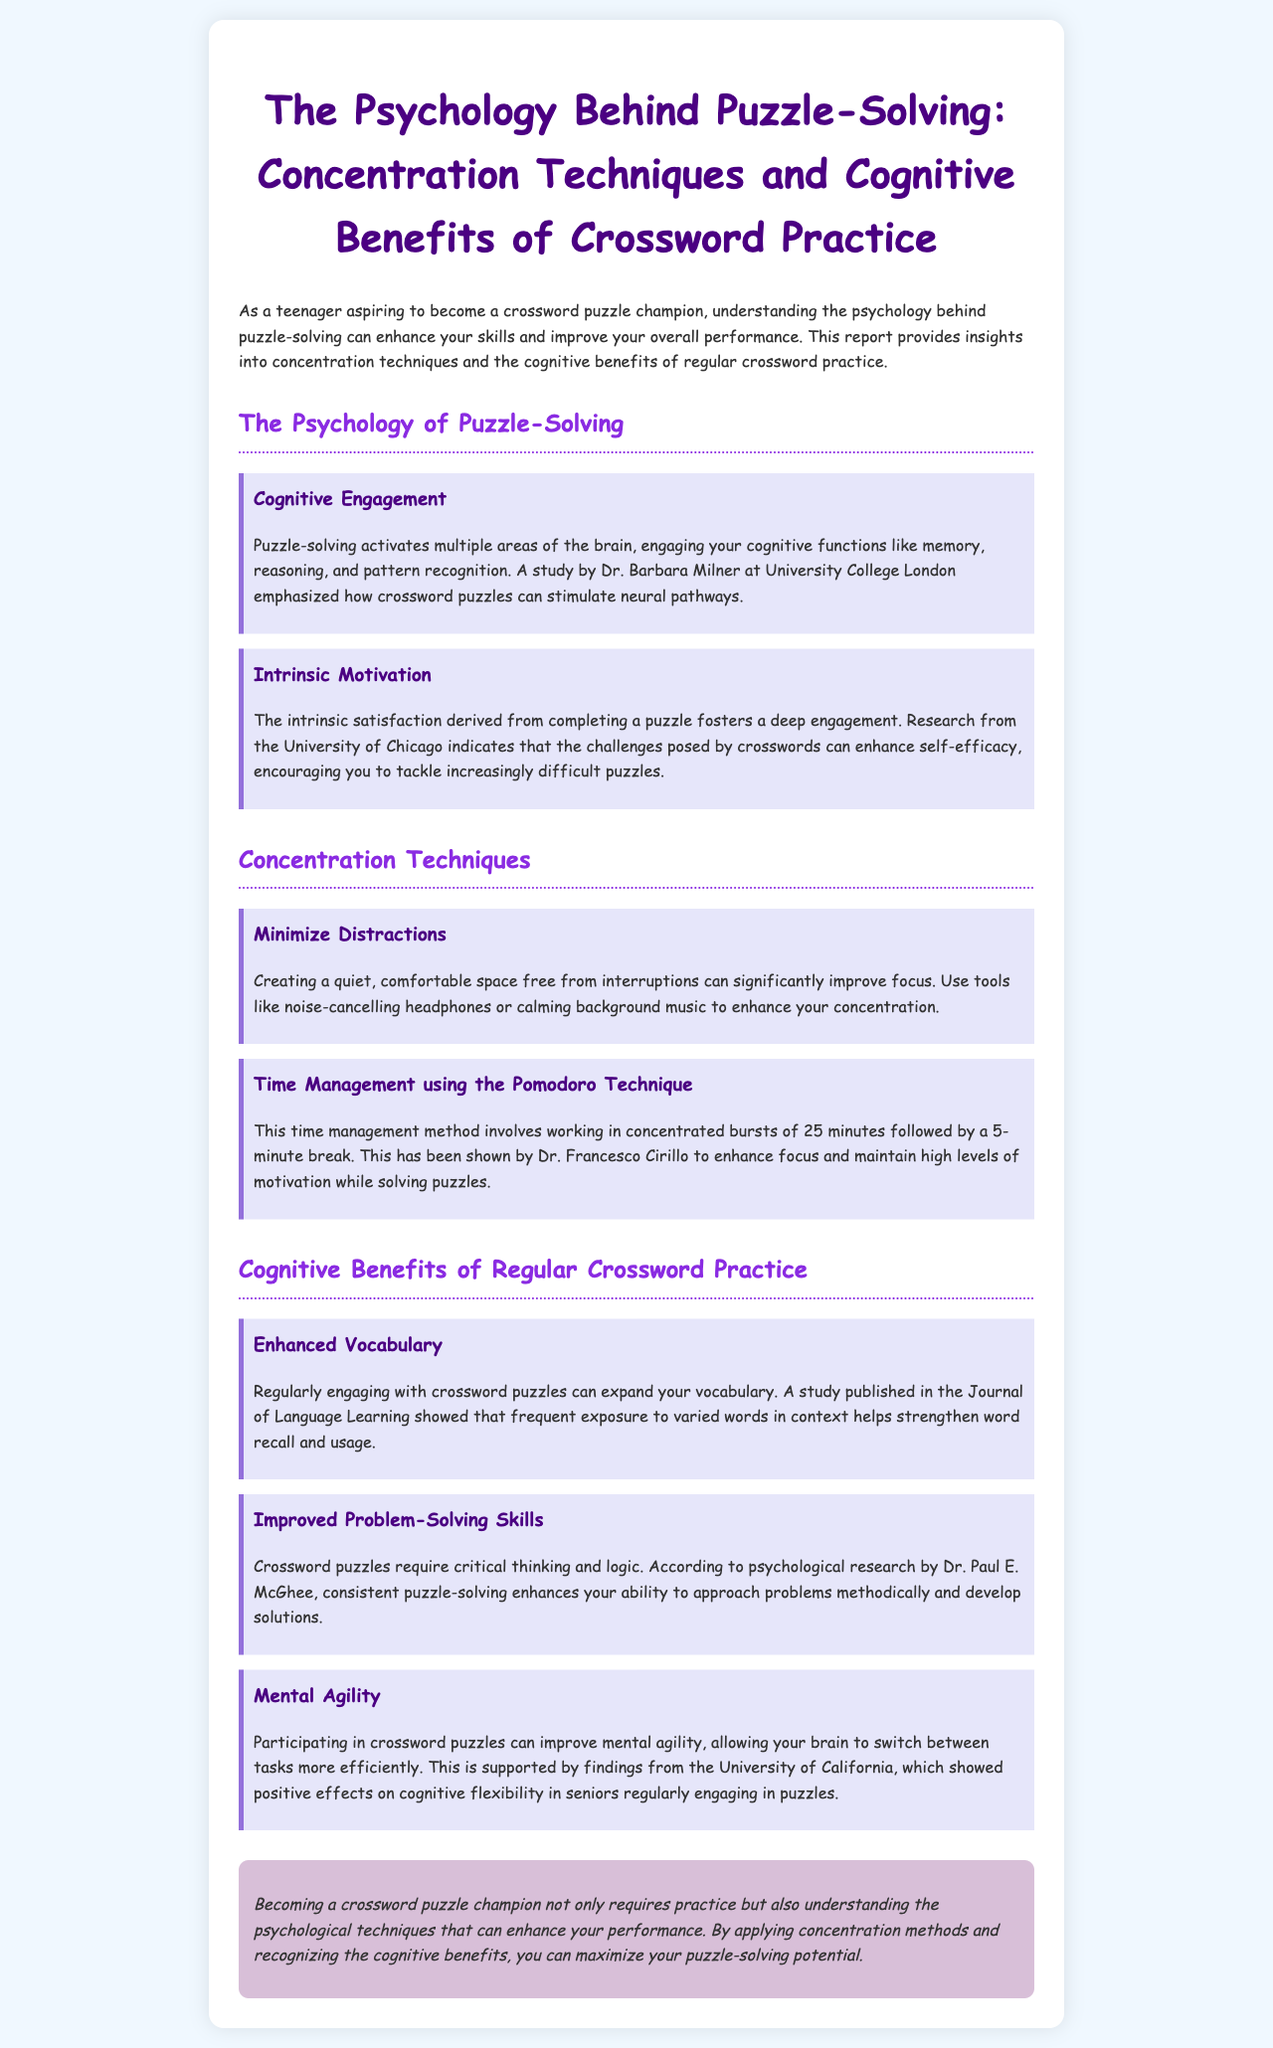What does puzzle-solving activate in the brain? Puzzle-solving activates multiple areas of the brain, engaging cognitive functions like memory, reasoning, and pattern recognition.
Answer: Multiple areas of the brain Who conducted a study that emphasized how crossword puzzles stimulate neural pathways? Dr. Barbara Milner at University College London emphasized how crossword puzzles can stimulate neural pathways.
Answer: Dr. Barbara Milner What intrinsic benefit can crossword puzzles enhance according to research? The challenges posed by crosswords can enhance self-efficacy.
Answer: Self-efficacy How long should a concentrated work session be in the Pomodoro Technique? This time management method involves working in concentrated bursts of 25 minutes.
Answer: 25 minutes Which benefit of regular crossword practice involves improving cognitive flexibility? A study showed positive effects on cognitive flexibility in seniors regularly engaging in puzzles.
Answer: Cognitive flexibility What is one technique suggested for improving focus while solving puzzles? Creating a quiet, comfortable space free from interruptions can significantly improve focus.
Answer: Minimize Distractions According to Dr. Paul E. McGhee, what do crossword puzzles enhance? Consistent puzzle-solving enhances your ability to approach problems methodically and develop solutions.
Answer: Problem-solving skills What can regular engagement with crossword puzzles help expand? Regularly engaging with crossword puzzles can expand your vocabulary.
Answer: Vocabulary 